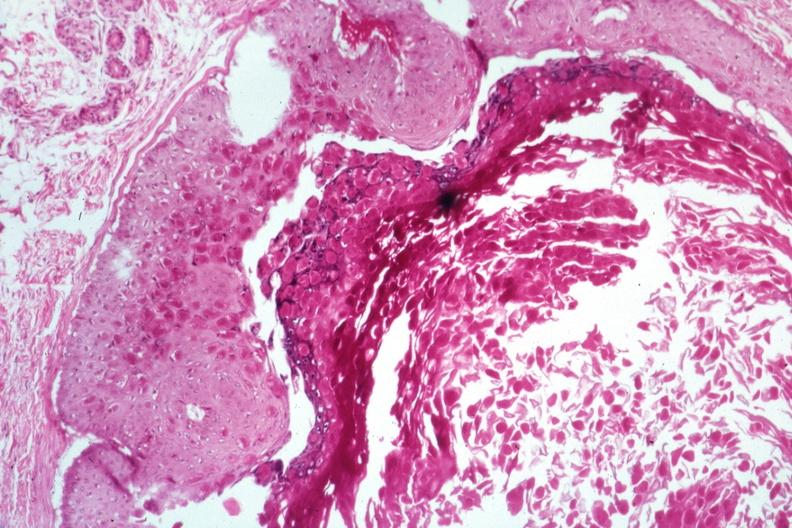what is present?
Answer the question using a single word or phrase. Molluscum contagiosum 